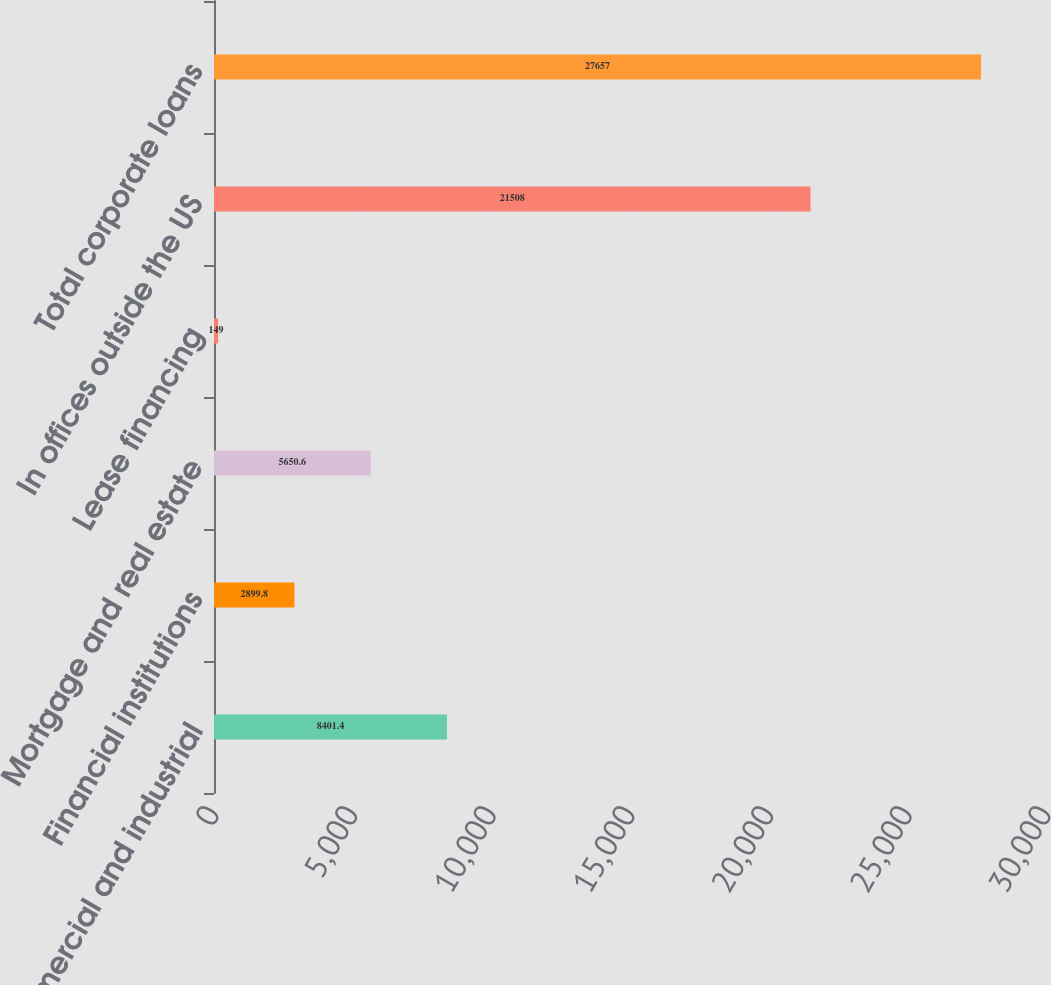Convert chart to OTSL. <chart><loc_0><loc_0><loc_500><loc_500><bar_chart><fcel>Commercial and industrial<fcel>Financial institutions<fcel>Mortgage and real estate<fcel>Lease financing<fcel>In offices outside the US<fcel>Total corporate loans<nl><fcel>8401.4<fcel>2899.8<fcel>5650.6<fcel>149<fcel>21508<fcel>27657<nl></chart> 